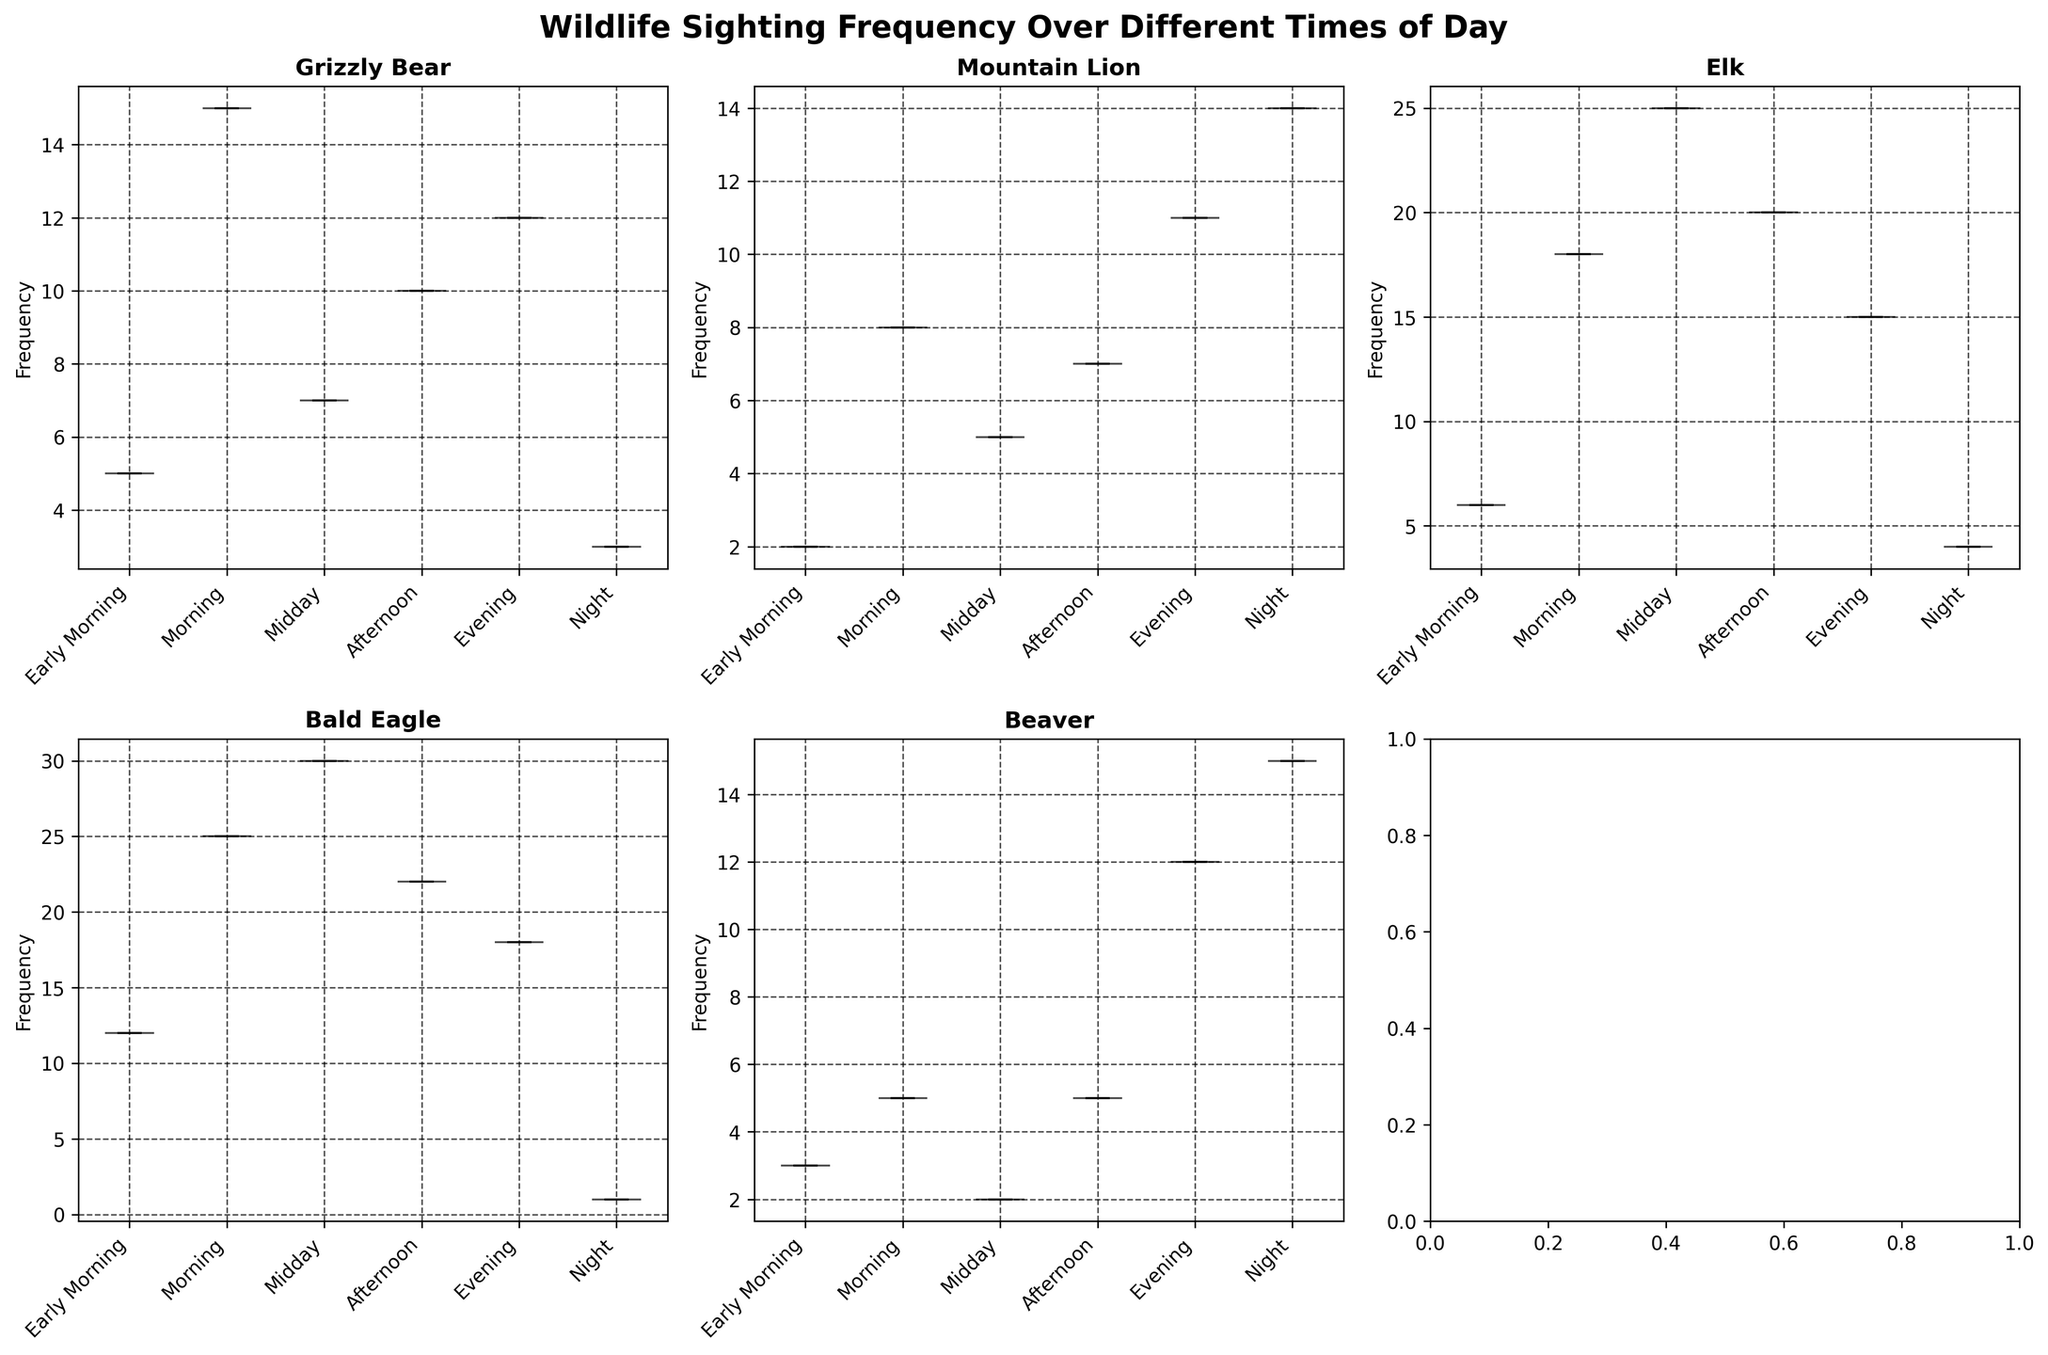What's the title of the figure? The title of the figure is usually located at the top of the plot. In this figure, it is "Wildlife Sighting Frequency Over Different Times of Day."
Answer: Wildlife Sighting Frequency Over Different Times of Day Which species has the highest frequency during Midday? By inspecting the violin plots for each species and their corresponding times of day, we see the highest frequency during Midday is for the Bald Eagle.
Answer: Bald Eagle What is the range of frequencies for the Beaver during the Night? In the violin plot for Beaver, the spread during the Night can be observed. The range is from the minimum to the maximum values shown. The range is from 0 to 15.
Answer: 0 to 15 How does the sighting frequency of Mountain Lion in the Evening compare to that of the Grizzly Bear in the Morning? By comparing the peaks of the violin plots for these two times, the Mountain Lion sighting frequency in the Evening (highest around 11) is lower than the Grizzly Bear sighting frequency in the Morning (highest around 15).
Answer: Lower What is the median sighting frequency for Elk during the Midday? In the figure, the median is marked by the line inside each violin plot. For Elk during Midday, the median line is at 25.
Answer: 25 Which animal has the least sighting frequency in the Early Morning? Inspecting the violin plots for Early Morning, the Mountain Lion has the least frequency with a value around 2.
Answer: Mountain Lion Is the spread of sightings for the Bald Eagle more concentrated during Midday or Morning? By inspecting the width of the violin plots, a narrower width indicates more concentration. The Bald Eagle's sighting frequency is more concentrated during Midday where the plot is narrower compared to the wider plot during Morning.
Answer: Midday How does the variability in Beaver sightings at Night compare to its variability in the Afternoon? The spread of the violin plots for Beaver indicates variability. The plot at Night is wider compared to that in the Afternoon, indicating higher variability.
Answer: Higher variability What is the highest frequency value for Grizzly Bear sightings during Evening? By checking the violin plot for Grizzly Bears during the Evening, the highest frequency value is at 12.
Answer: 12 During which time of day are Elk sightings most variable? The violin plot for the Elk is widest during Midday, indicating most variability in sightings.
Answer: Midday 